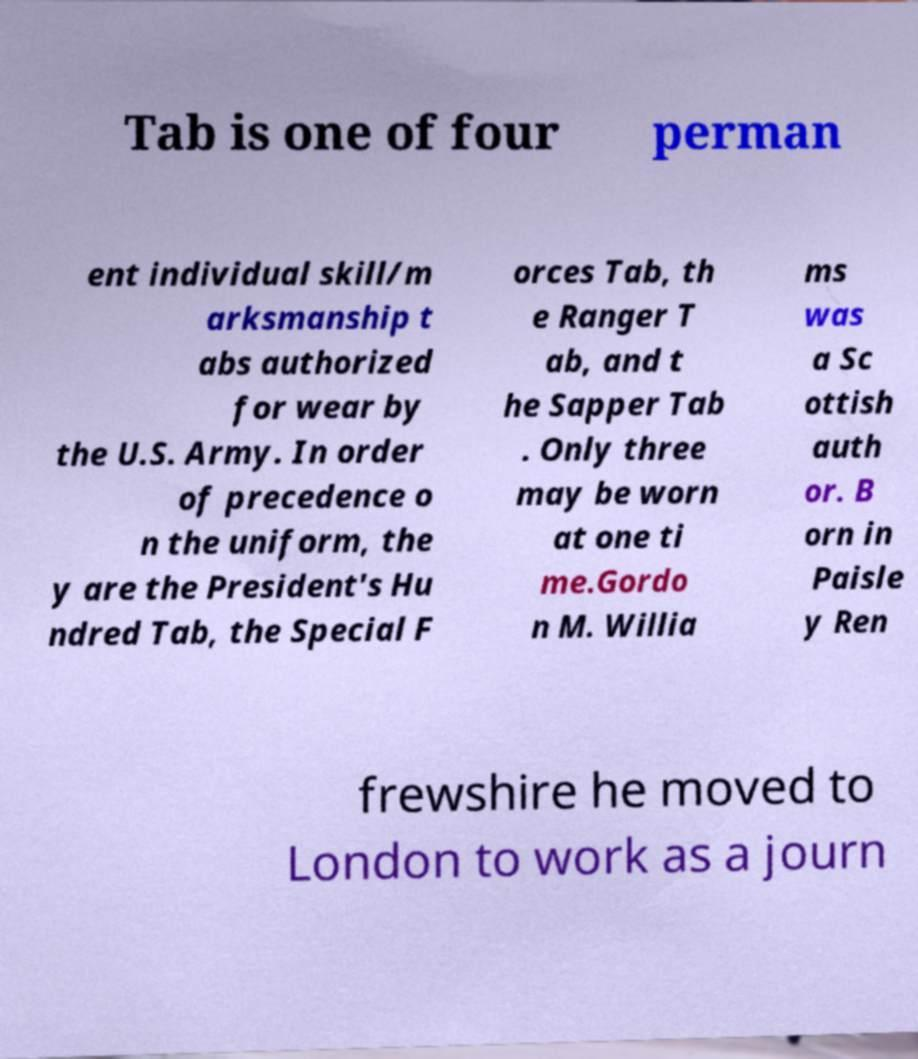Can you read and provide the text displayed in the image?This photo seems to have some interesting text. Can you extract and type it out for me? Tab is one of four perman ent individual skill/m arksmanship t abs authorized for wear by the U.S. Army. In order of precedence o n the uniform, the y are the President's Hu ndred Tab, the Special F orces Tab, th e Ranger T ab, and t he Sapper Tab . Only three may be worn at one ti me.Gordo n M. Willia ms was a Sc ottish auth or. B orn in Paisle y Ren frewshire he moved to London to work as a journ 